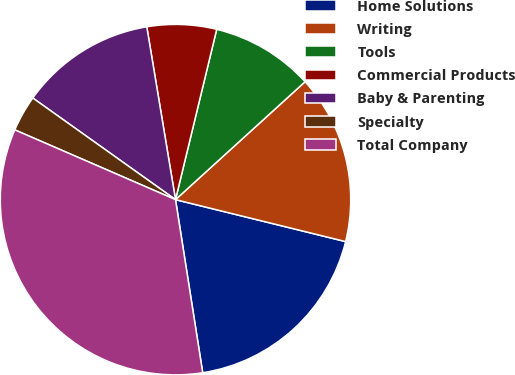Convert chart to OTSL. <chart><loc_0><loc_0><loc_500><loc_500><pie_chart><fcel>Home Solutions<fcel>Writing<fcel>Tools<fcel>Commercial Products<fcel>Baby & Parenting<fcel>Specialty<fcel>Total Company<nl><fcel>18.67%<fcel>15.6%<fcel>9.47%<fcel>6.4%<fcel>12.53%<fcel>3.33%<fcel>34.0%<nl></chart> 